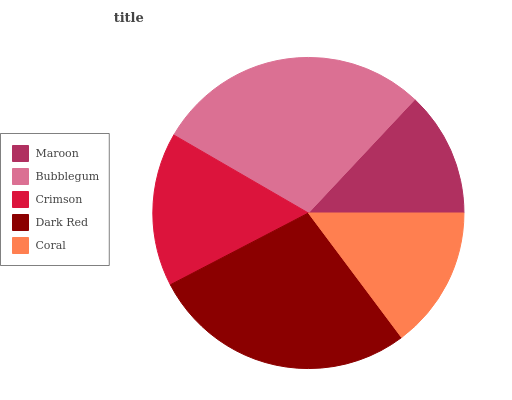Is Maroon the minimum?
Answer yes or no. Yes. Is Bubblegum the maximum?
Answer yes or no. Yes. Is Crimson the minimum?
Answer yes or no. No. Is Crimson the maximum?
Answer yes or no. No. Is Bubblegum greater than Crimson?
Answer yes or no. Yes. Is Crimson less than Bubblegum?
Answer yes or no. Yes. Is Crimson greater than Bubblegum?
Answer yes or no. No. Is Bubblegum less than Crimson?
Answer yes or no. No. Is Crimson the high median?
Answer yes or no. Yes. Is Crimson the low median?
Answer yes or no. Yes. Is Coral the high median?
Answer yes or no. No. Is Bubblegum the low median?
Answer yes or no. No. 